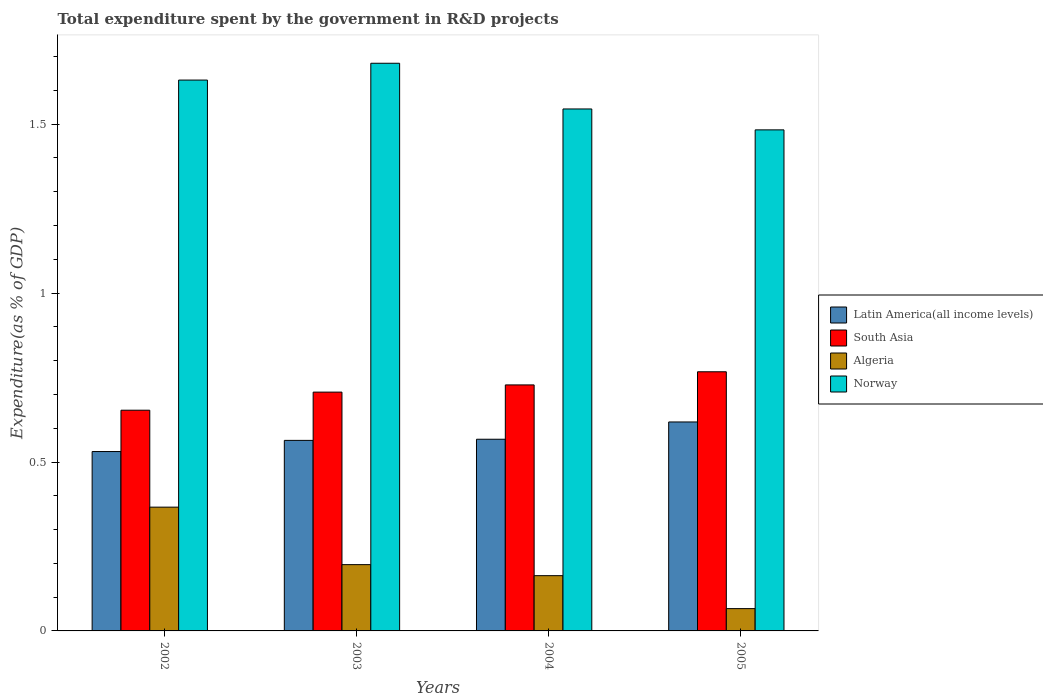How many different coloured bars are there?
Offer a terse response. 4. Are the number of bars per tick equal to the number of legend labels?
Keep it short and to the point. Yes. Are the number of bars on each tick of the X-axis equal?
Give a very brief answer. Yes. How many bars are there on the 2nd tick from the right?
Ensure brevity in your answer.  4. In how many cases, is the number of bars for a given year not equal to the number of legend labels?
Provide a succinct answer. 0. What is the total expenditure spent by the government in R&D projects in Algeria in 2003?
Give a very brief answer. 0.2. Across all years, what is the maximum total expenditure spent by the government in R&D projects in Latin America(all income levels)?
Your response must be concise. 0.62. Across all years, what is the minimum total expenditure spent by the government in R&D projects in Latin America(all income levels)?
Give a very brief answer. 0.53. In which year was the total expenditure spent by the government in R&D projects in Norway maximum?
Ensure brevity in your answer.  2003. What is the total total expenditure spent by the government in R&D projects in Norway in the graph?
Your response must be concise. 6.34. What is the difference between the total expenditure spent by the government in R&D projects in Norway in 2002 and that in 2005?
Provide a short and direct response. 0.15. What is the difference between the total expenditure spent by the government in R&D projects in Latin America(all income levels) in 2005 and the total expenditure spent by the government in R&D projects in South Asia in 2004?
Your answer should be compact. -0.11. What is the average total expenditure spent by the government in R&D projects in Algeria per year?
Your response must be concise. 0.2. In the year 2005, what is the difference between the total expenditure spent by the government in R&D projects in Norway and total expenditure spent by the government in R&D projects in South Asia?
Keep it short and to the point. 0.72. What is the ratio of the total expenditure spent by the government in R&D projects in Algeria in 2002 to that in 2003?
Provide a short and direct response. 1.87. What is the difference between the highest and the second highest total expenditure spent by the government in R&D projects in South Asia?
Ensure brevity in your answer.  0.04. What is the difference between the highest and the lowest total expenditure spent by the government in R&D projects in Algeria?
Make the answer very short. 0.3. In how many years, is the total expenditure spent by the government in R&D projects in Latin America(all income levels) greater than the average total expenditure spent by the government in R&D projects in Latin America(all income levels) taken over all years?
Provide a succinct answer. 1. Is the sum of the total expenditure spent by the government in R&D projects in South Asia in 2003 and 2004 greater than the maximum total expenditure spent by the government in R&D projects in Algeria across all years?
Keep it short and to the point. Yes. Is it the case that in every year, the sum of the total expenditure spent by the government in R&D projects in South Asia and total expenditure spent by the government in R&D projects in Latin America(all income levels) is greater than the sum of total expenditure spent by the government in R&D projects in Algeria and total expenditure spent by the government in R&D projects in Norway?
Your answer should be compact. No. What does the 1st bar from the left in 2004 represents?
Ensure brevity in your answer.  Latin America(all income levels). Is it the case that in every year, the sum of the total expenditure spent by the government in R&D projects in Norway and total expenditure spent by the government in R&D projects in Latin America(all income levels) is greater than the total expenditure spent by the government in R&D projects in South Asia?
Provide a short and direct response. Yes. How many bars are there?
Provide a short and direct response. 16. Are all the bars in the graph horizontal?
Your answer should be compact. No. How many years are there in the graph?
Your answer should be very brief. 4. What is the difference between two consecutive major ticks on the Y-axis?
Your response must be concise. 0.5. Are the values on the major ticks of Y-axis written in scientific E-notation?
Provide a succinct answer. No. How are the legend labels stacked?
Your answer should be compact. Vertical. What is the title of the graph?
Provide a short and direct response. Total expenditure spent by the government in R&D projects. Does "Cayman Islands" appear as one of the legend labels in the graph?
Offer a very short reply. No. What is the label or title of the X-axis?
Offer a very short reply. Years. What is the label or title of the Y-axis?
Provide a short and direct response. Expenditure(as % of GDP). What is the Expenditure(as % of GDP) of Latin America(all income levels) in 2002?
Keep it short and to the point. 0.53. What is the Expenditure(as % of GDP) of South Asia in 2002?
Offer a very short reply. 0.65. What is the Expenditure(as % of GDP) in Algeria in 2002?
Provide a short and direct response. 0.37. What is the Expenditure(as % of GDP) of Norway in 2002?
Offer a terse response. 1.63. What is the Expenditure(as % of GDP) in Latin America(all income levels) in 2003?
Provide a short and direct response. 0.56. What is the Expenditure(as % of GDP) of South Asia in 2003?
Keep it short and to the point. 0.71. What is the Expenditure(as % of GDP) in Algeria in 2003?
Offer a terse response. 0.2. What is the Expenditure(as % of GDP) in Norway in 2003?
Your response must be concise. 1.68. What is the Expenditure(as % of GDP) in Latin America(all income levels) in 2004?
Keep it short and to the point. 0.57. What is the Expenditure(as % of GDP) in South Asia in 2004?
Provide a short and direct response. 0.73. What is the Expenditure(as % of GDP) of Algeria in 2004?
Provide a short and direct response. 0.16. What is the Expenditure(as % of GDP) in Norway in 2004?
Your answer should be very brief. 1.55. What is the Expenditure(as % of GDP) in Latin America(all income levels) in 2005?
Make the answer very short. 0.62. What is the Expenditure(as % of GDP) of South Asia in 2005?
Your answer should be very brief. 0.77. What is the Expenditure(as % of GDP) of Algeria in 2005?
Provide a short and direct response. 0.07. What is the Expenditure(as % of GDP) in Norway in 2005?
Your answer should be very brief. 1.48. Across all years, what is the maximum Expenditure(as % of GDP) in Latin America(all income levels)?
Offer a terse response. 0.62. Across all years, what is the maximum Expenditure(as % of GDP) of South Asia?
Give a very brief answer. 0.77. Across all years, what is the maximum Expenditure(as % of GDP) of Algeria?
Provide a succinct answer. 0.37. Across all years, what is the maximum Expenditure(as % of GDP) of Norway?
Keep it short and to the point. 1.68. Across all years, what is the minimum Expenditure(as % of GDP) of Latin America(all income levels)?
Keep it short and to the point. 0.53. Across all years, what is the minimum Expenditure(as % of GDP) of South Asia?
Keep it short and to the point. 0.65. Across all years, what is the minimum Expenditure(as % of GDP) of Algeria?
Keep it short and to the point. 0.07. Across all years, what is the minimum Expenditure(as % of GDP) of Norway?
Provide a short and direct response. 1.48. What is the total Expenditure(as % of GDP) in Latin America(all income levels) in the graph?
Provide a short and direct response. 2.28. What is the total Expenditure(as % of GDP) of South Asia in the graph?
Ensure brevity in your answer.  2.86. What is the total Expenditure(as % of GDP) in Algeria in the graph?
Offer a very short reply. 0.79. What is the total Expenditure(as % of GDP) of Norway in the graph?
Keep it short and to the point. 6.34. What is the difference between the Expenditure(as % of GDP) in Latin America(all income levels) in 2002 and that in 2003?
Ensure brevity in your answer.  -0.03. What is the difference between the Expenditure(as % of GDP) of South Asia in 2002 and that in 2003?
Your response must be concise. -0.05. What is the difference between the Expenditure(as % of GDP) in Algeria in 2002 and that in 2003?
Ensure brevity in your answer.  0.17. What is the difference between the Expenditure(as % of GDP) in Norway in 2002 and that in 2003?
Ensure brevity in your answer.  -0.05. What is the difference between the Expenditure(as % of GDP) in Latin America(all income levels) in 2002 and that in 2004?
Offer a very short reply. -0.04. What is the difference between the Expenditure(as % of GDP) of South Asia in 2002 and that in 2004?
Provide a short and direct response. -0.07. What is the difference between the Expenditure(as % of GDP) of Algeria in 2002 and that in 2004?
Ensure brevity in your answer.  0.2. What is the difference between the Expenditure(as % of GDP) in Norway in 2002 and that in 2004?
Keep it short and to the point. 0.09. What is the difference between the Expenditure(as % of GDP) in Latin America(all income levels) in 2002 and that in 2005?
Give a very brief answer. -0.09. What is the difference between the Expenditure(as % of GDP) of South Asia in 2002 and that in 2005?
Provide a succinct answer. -0.11. What is the difference between the Expenditure(as % of GDP) of Algeria in 2002 and that in 2005?
Your answer should be very brief. 0.3. What is the difference between the Expenditure(as % of GDP) of Norway in 2002 and that in 2005?
Give a very brief answer. 0.15. What is the difference between the Expenditure(as % of GDP) of Latin America(all income levels) in 2003 and that in 2004?
Offer a very short reply. -0. What is the difference between the Expenditure(as % of GDP) of South Asia in 2003 and that in 2004?
Keep it short and to the point. -0.02. What is the difference between the Expenditure(as % of GDP) of Algeria in 2003 and that in 2004?
Provide a succinct answer. 0.03. What is the difference between the Expenditure(as % of GDP) in Norway in 2003 and that in 2004?
Offer a terse response. 0.14. What is the difference between the Expenditure(as % of GDP) of Latin America(all income levels) in 2003 and that in 2005?
Keep it short and to the point. -0.05. What is the difference between the Expenditure(as % of GDP) of South Asia in 2003 and that in 2005?
Offer a terse response. -0.06. What is the difference between the Expenditure(as % of GDP) of Algeria in 2003 and that in 2005?
Keep it short and to the point. 0.13. What is the difference between the Expenditure(as % of GDP) in Norway in 2003 and that in 2005?
Provide a succinct answer. 0.2. What is the difference between the Expenditure(as % of GDP) of Latin America(all income levels) in 2004 and that in 2005?
Offer a terse response. -0.05. What is the difference between the Expenditure(as % of GDP) in South Asia in 2004 and that in 2005?
Your response must be concise. -0.04. What is the difference between the Expenditure(as % of GDP) in Algeria in 2004 and that in 2005?
Your answer should be very brief. 0.1. What is the difference between the Expenditure(as % of GDP) of Norway in 2004 and that in 2005?
Offer a terse response. 0.06. What is the difference between the Expenditure(as % of GDP) of Latin America(all income levels) in 2002 and the Expenditure(as % of GDP) of South Asia in 2003?
Keep it short and to the point. -0.18. What is the difference between the Expenditure(as % of GDP) in Latin America(all income levels) in 2002 and the Expenditure(as % of GDP) in Algeria in 2003?
Make the answer very short. 0.33. What is the difference between the Expenditure(as % of GDP) of Latin America(all income levels) in 2002 and the Expenditure(as % of GDP) of Norway in 2003?
Provide a succinct answer. -1.15. What is the difference between the Expenditure(as % of GDP) of South Asia in 2002 and the Expenditure(as % of GDP) of Algeria in 2003?
Offer a very short reply. 0.46. What is the difference between the Expenditure(as % of GDP) in South Asia in 2002 and the Expenditure(as % of GDP) in Norway in 2003?
Offer a terse response. -1.03. What is the difference between the Expenditure(as % of GDP) of Algeria in 2002 and the Expenditure(as % of GDP) of Norway in 2003?
Provide a succinct answer. -1.31. What is the difference between the Expenditure(as % of GDP) in Latin America(all income levels) in 2002 and the Expenditure(as % of GDP) in South Asia in 2004?
Keep it short and to the point. -0.2. What is the difference between the Expenditure(as % of GDP) of Latin America(all income levels) in 2002 and the Expenditure(as % of GDP) of Algeria in 2004?
Offer a terse response. 0.37. What is the difference between the Expenditure(as % of GDP) of Latin America(all income levels) in 2002 and the Expenditure(as % of GDP) of Norway in 2004?
Your answer should be very brief. -1.01. What is the difference between the Expenditure(as % of GDP) in South Asia in 2002 and the Expenditure(as % of GDP) in Algeria in 2004?
Provide a succinct answer. 0.49. What is the difference between the Expenditure(as % of GDP) of South Asia in 2002 and the Expenditure(as % of GDP) of Norway in 2004?
Ensure brevity in your answer.  -0.89. What is the difference between the Expenditure(as % of GDP) in Algeria in 2002 and the Expenditure(as % of GDP) in Norway in 2004?
Your answer should be very brief. -1.18. What is the difference between the Expenditure(as % of GDP) of Latin America(all income levels) in 2002 and the Expenditure(as % of GDP) of South Asia in 2005?
Your answer should be compact. -0.24. What is the difference between the Expenditure(as % of GDP) of Latin America(all income levels) in 2002 and the Expenditure(as % of GDP) of Algeria in 2005?
Ensure brevity in your answer.  0.46. What is the difference between the Expenditure(as % of GDP) of Latin America(all income levels) in 2002 and the Expenditure(as % of GDP) of Norway in 2005?
Make the answer very short. -0.95. What is the difference between the Expenditure(as % of GDP) of South Asia in 2002 and the Expenditure(as % of GDP) of Algeria in 2005?
Your answer should be compact. 0.59. What is the difference between the Expenditure(as % of GDP) of South Asia in 2002 and the Expenditure(as % of GDP) of Norway in 2005?
Ensure brevity in your answer.  -0.83. What is the difference between the Expenditure(as % of GDP) of Algeria in 2002 and the Expenditure(as % of GDP) of Norway in 2005?
Your answer should be very brief. -1.12. What is the difference between the Expenditure(as % of GDP) of Latin America(all income levels) in 2003 and the Expenditure(as % of GDP) of South Asia in 2004?
Offer a terse response. -0.16. What is the difference between the Expenditure(as % of GDP) in Latin America(all income levels) in 2003 and the Expenditure(as % of GDP) in Algeria in 2004?
Provide a short and direct response. 0.4. What is the difference between the Expenditure(as % of GDP) in Latin America(all income levels) in 2003 and the Expenditure(as % of GDP) in Norway in 2004?
Ensure brevity in your answer.  -0.98. What is the difference between the Expenditure(as % of GDP) of South Asia in 2003 and the Expenditure(as % of GDP) of Algeria in 2004?
Your answer should be compact. 0.54. What is the difference between the Expenditure(as % of GDP) of South Asia in 2003 and the Expenditure(as % of GDP) of Norway in 2004?
Offer a very short reply. -0.84. What is the difference between the Expenditure(as % of GDP) in Algeria in 2003 and the Expenditure(as % of GDP) in Norway in 2004?
Offer a very short reply. -1.35. What is the difference between the Expenditure(as % of GDP) of Latin America(all income levels) in 2003 and the Expenditure(as % of GDP) of South Asia in 2005?
Make the answer very short. -0.2. What is the difference between the Expenditure(as % of GDP) of Latin America(all income levels) in 2003 and the Expenditure(as % of GDP) of Algeria in 2005?
Offer a very short reply. 0.5. What is the difference between the Expenditure(as % of GDP) of Latin America(all income levels) in 2003 and the Expenditure(as % of GDP) of Norway in 2005?
Ensure brevity in your answer.  -0.92. What is the difference between the Expenditure(as % of GDP) of South Asia in 2003 and the Expenditure(as % of GDP) of Algeria in 2005?
Make the answer very short. 0.64. What is the difference between the Expenditure(as % of GDP) in South Asia in 2003 and the Expenditure(as % of GDP) in Norway in 2005?
Offer a very short reply. -0.78. What is the difference between the Expenditure(as % of GDP) of Algeria in 2003 and the Expenditure(as % of GDP) of Norway in 2005?
Offer a terse response. -1.29. What is the difference between the Expenditure(as % of GDP) of Latin America(all income levels) in 2004 and the Expenditure(as % of GDP) of South Asia in 2005?
Ensure brevity in your answer.  -0.2. What is the difference between the Expenditure(as % of GDP) in Latin America(all income levels) in 2004 and the Expenditure(as % of GDP) in Algeria in 2005?
Your answer should be very brief. 0.5. What is the difference between the Expenditure(as % of GDP) in Latin America(all income levels) in 2004 and the Expenditure(as % of GDP) in Norway in 2005?
Provide a short and direct response. -0.92. What is the difference between the Expenditure(as % of GDP) of South Asia in 2004 and the Expenditure(as % of GDP) of Algeria in 2005?
Ensure brevity in your answer.  0.66. What is the difference between the Expenditure(as % of GDP) in South Asia in 2004 and the Expenditure(as % of GDP) in Norway in 2005?
Your response must be concise. -0.76. What is the difference between the Expenditure(as % of GDP) in Algeria in 2004 and the Expenditure(as % of GDP) in Norway in 2005?
Provide a succinct answer. -1.32. What is the average Expenditure(as % of GDP) of Latin America(all income levels) per year?
Your response must be concise. 0.57. What is the average Expenditure(as % of GDP) of South Asia per year?
Provide a succinct answer. 0.71. What is the average Expenditure(as % of GDP) of Algeria per year?
Provide a short and direct response. 0.2. What is the average Expenditure(as % of GDP) of Norway per year?
Offer a terse response. 1.58. In the year 2002, what is the difference between the Expenditure(as % of GDP) of Latin America(all income levels) and Expenditure(as % of GDP) of South Asia?
Keep it short and to the point. -0.12. In the year 2002, what is the difference between the Expenditure(as % of GDP) of Latin America(all income levels) and Expenditure(as % of GDP) of Algeria?
Your answer should be compact. 0.16. In the year 2002, what is the difference between the Expenditure(as % of GDP) of Latin America(all income levels) and Expenditure(as % of GDP) of Norway?
Keep it short and to the point. -1.1. In the year 2002, what is the difference between the Expenditure(as % of GDP) in South Asia and Expenditure(as % of GDP) in Algeria?
Offer a terse response. 0.29. In the year 2002, what is the difference between the Expenditure(as % of GDP) of South Asia and Expenditure(as % of GDP) of Norway?
Your response must be concise. -0.98. In the year 2002, what is the difference between the Expenditure(as % of GDP) of Algeria and Expenditure(as % of GDP) of Norway?
Offer a terse response. -1.26. In the year 2003, what is the difference between the Expenditure(as % of GDP) in Latin America(all income levels) and Expenditure(as % of GDP) in South Asia?
Your answer should be very brief. -0.14. In the year 2003, what is the difference between the Expenditure(as % of GDP) of Latin America(all income levels) and Expenditure(as % of GDP) of Algeria?
Your answer should be very brief. 0.37. In the year 2003, what is the difference between the Expenditure(as % of GDP) in Latin America(all income levels) and Expenditure(as % of GDP) in Norway?
Offer a very short reply. -1.12. In the year 2003, what is the difference between the Expenditure(as % of GDP) of South Asia and Expenditure(as % of GDP) of Algeria?
Your answer should be very brief. 0.51. In the year 2003, what is the difference between the Expenditure(as % of GDP) of South Asia and Expenditure(as % of GDP) of Norway?
Ensure brevity in your answer.  -0.97. In the year 2003, what is the difference between the Expenditure(as % of GDP) in Algeria and Expenditure(as % of GDP) in Norway?
Ensure brevity in your answer.  -1.48. In the year 2004, what is the difference between the Expenditure(as % of GDP) of Latin America(all income levels) and Expenditure(as % of GDP) of South Asia?
Ensure brevity in your answer.  -0.16. In the year 2004, what is the difference between the Expenditure(as % of GDP) of Latin America(all income levels) and Expenditure(as % of GDP) of Algeria?
Give a very brief answer. 0.4. In the year 2004, what is the difference between the Expenditure(as % of GDP) of Latin America(all income levels) and Expenditure(as % of GDP) of Norway?
Make the answer very short. -0.98. In the year 2004, what is the difference between the Expenditure(as % of GDP) in South Asia and Expenditure(as % of GDP) in Algeria?
Your answer should be very brief. 0.56. In the year 2004, what is the difference between the Expenditure(as % of GDP) in South Asia and Expenditure(as % of GDP) in Norway?
Make the answer very short. -0.82. In the year 2004, what is the difference between the Expenditure(as % of GDP) of Algeria and Expenditure(as % of GDP) of Norway?
Ensure brevity in your answer.  -1.38. In the year 2005, what is the difference between the Expenditure(as % of GDP) of Latin America(all income levels) and Expenditure(as % of GDP) of South Asia?
Ensure brevity in your answer.  -0.15. In the year 2005, what is the difference between the Expenditure(as % of GDP) in Latin America(all income levels) and Expenditure(as % of GDP) in Algeria?
Provide a succinct answer. 0.55. In the year 2005, what is the difference between the Expenditure(as % of GDP) of Latin America(all income levels) and Expenditure(as % of GDP) of Norway?
Make the answer very short. -0.86. In the year 2005, what is the difference between the Expenditure(as % of GDP) in South Asia and Expenditure(as % of GDP) in Algeria?
Give a very brief answer. 0.7. In the year 2005, what is the difference between the Expenditure(as % of GDP) of South Asia and Expenditure(as % of GDP) of Norway?
Keep it short and to the point. -0.72. In the year 2005, what is the difference between the Expenditure(as % of GDP) of Algeria and Expenditure(as % of GDP) of Norway?
Your response must be concise. -1.42. What is the ratio of the Expenditure(as % of GDP) in Latin America(all income levels) in 2002 to that in 2003?
Offer a very short reply. 0.94. What is the ratio of the Expenditure(as % of GDP) in South Asia in 2002 to that in 2003?
Give a very brief answer. 0.92. What is the ratio of the Expenditure(as % of GDP) in Algeria in 2002 to that in 2003?
Offer a very short reply. 1.87. What is the ratio of the Expenditure(as % of GDP) of Norway in 2002 to that in 2003?
Ensure brevity in your answer.  0.97. What is the ratio of the Expenditure(as % of GDP) of Latin America(all income levels) in 2002 to that in 2004?
Provide a short and direct response. 0.94. What is the ratio of the Expenditure(as % of GDP) in South Asia in 2002 to that in 2004?
Ensure brevity in your answer.  0.9. What is the ratio of the Expenditure(as % of GDP) in Algeria in 2002 to that in 2004?
Offer a very short reply. 2.24. What is the ratio of the Expenditure(as % of GDP) in Norway in 2002 to that in 2004?
Ensure brevity in your answer.  1.06. What is the ratio of the Expenditure(as % of GDP) in Latin America(all income levels) in 2002 to that in 2005?
Give a very brief answer. 0.86. What is the ratio of the Expenditure(as % of GDP) of South Asia in 2002 to that in 2005?
Your response must be concise. 0.85. What is the ratio of the Expenditure(as % of GDP) of Algeria in 2002 to that in 2005?
Keep it short and to the point. 5.55. What is the ratio of the Expenditure(as % of GDP) of Norway in 2002 to that in 2005?
Keep it short and to the point. 1.1. What is the ratio of the Expenditure(as % of GDP) in South Asia in 2003 to that in 2004?
Ensure brevity in your answer.  0.97. What is the ratio of the Expenditure(as % of GDP) of Algeria in 2003 to that in 2004?
Your answer should be compact. 1.2. What is the ratio of the Expenditure(as % of GDP) of Norway in 2003 to that in 2004?
Ensure brevity in your answer.  1.09. What is the ratio of the Expenditure(as % of GDP) of Latin America(all income levels) in 2003 to that in 2005?
Provide a short and direct response. 0.91. What is the ratio of the Expenditure(as % of GDP) in South Asia in 2003 to that in 2005?
Your answer should be compact. 0.92. What is the ratio of the Expenditure(as % of GDP) in Algeria in 2003 to that in 2005?
Keep it short and to the point. 2.97. What is the ratio of the Expenditure(as % of GDP) of Norway in 2003 to that in 2005?
Your answer should be very brief. 1.13. What is the ratio of the Expenditure(as % of GDP) of Latin America(all income levels) in 2004 to that in 2005?
Offer a terse response. 0.92. What is the ratio of the Expenditure(as % of GDP) in South Asia in 2004 to that in 2005?
Your answer should be very brief. 0.95. What is the ratio of the Expenditure(as % of GDP) in Algeria in 2004 to that in 2005?
Your response must be concise. 2.48. What is the ratio of the Expenditure(as % of GDP) in Norway in 2004 to that in 2005?
Provide a succinct answer. 1.04. What is the difference between the highest and the second highest Expenditure(as % of GDP) in Latin America(all income levels)?
Your response must be concise. 0.05. What is the difference between the highest and the second highest Expenditure(as % of GDP) in South Asia?
Your response must be concise. 0.04. What is the difference between the highest and the second highest Expenditure(as % of GDP) of Algeria?
Offer a terse response. 0.17. What is the difference between the highest and the second highest Expenditure(as % of GDP) of Norway?
Provide a short and direct response. 0.05. What is the difference between the highest and the lowest Expenditure(as % of GDP) in Latin America(all income levels)?
Offer a very short reply. 0.09. What is the difference between the highest and the lowest Expenditure(as % of GDP) of South Asia?
Give a very brief answer. 0.11. What is the difference between the highest and the lowest Expenditure(as % of GDP) of Algeria?
Your response must be concise. 0.3. What is the difference between the highest and the lowest Expenditure(as % of GDP) in Norway?
Provide a short and direct response. 0.2. 